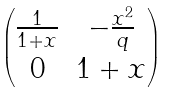<formula> <loc_0><loc_0><loc_500><loc_500>\begin{pmatrix} \frac { 1 } { 1 + x } & - \frac { x ^ { 2 } } { q } \\ 0 & 1 + x \end{pmatrix}</formula> 